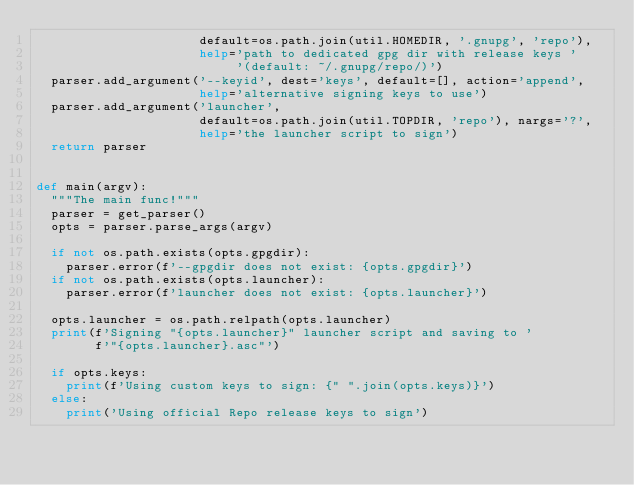<code> <loc_0><loc_0><loc_500><loc_500><_Python_>                      default=os.path.join(util.HOMEDIR, '.gnupg', 'repo'),
                      help='path to dedicated gpg dir with release keys '
                           '(default: ~/.gnupg/repo/)')
  parser.add_argument('--keyid', dest='keys', default=[], action='append',
                      help='alternative signing keys to use')
  parser.add_argument('launcher',
                      default=os.path.join(util.TOPDIR, 'repo'), nargs='?',
                      help='the launcher script to sign')
  return parser


def main(argv):
  """The main func!"""
  parser = get_parser()
  opts = parser.parse_args(argv)

  if not os.path.exists(opts.gpgdir):
    parser.error(f'--gpgdir does not exist: {opts.gpgdir}')
  if not os.path.exists(opts.launcher):
    parser.error(f'launcher does not exist: {opts.launcher}')

  opts.launcher = os.path.relpath(opts.launcher)
  print(f'Signing "{opts.launcher}" launcher script and saving to '
        f'"{opts.launcher}.asc"')

  if opts.keys:
    print(f'Using custom keys to sign: {" ".join(opts.keys)}')
  else:
    print('Using official Repo release keys to sign')</code> 